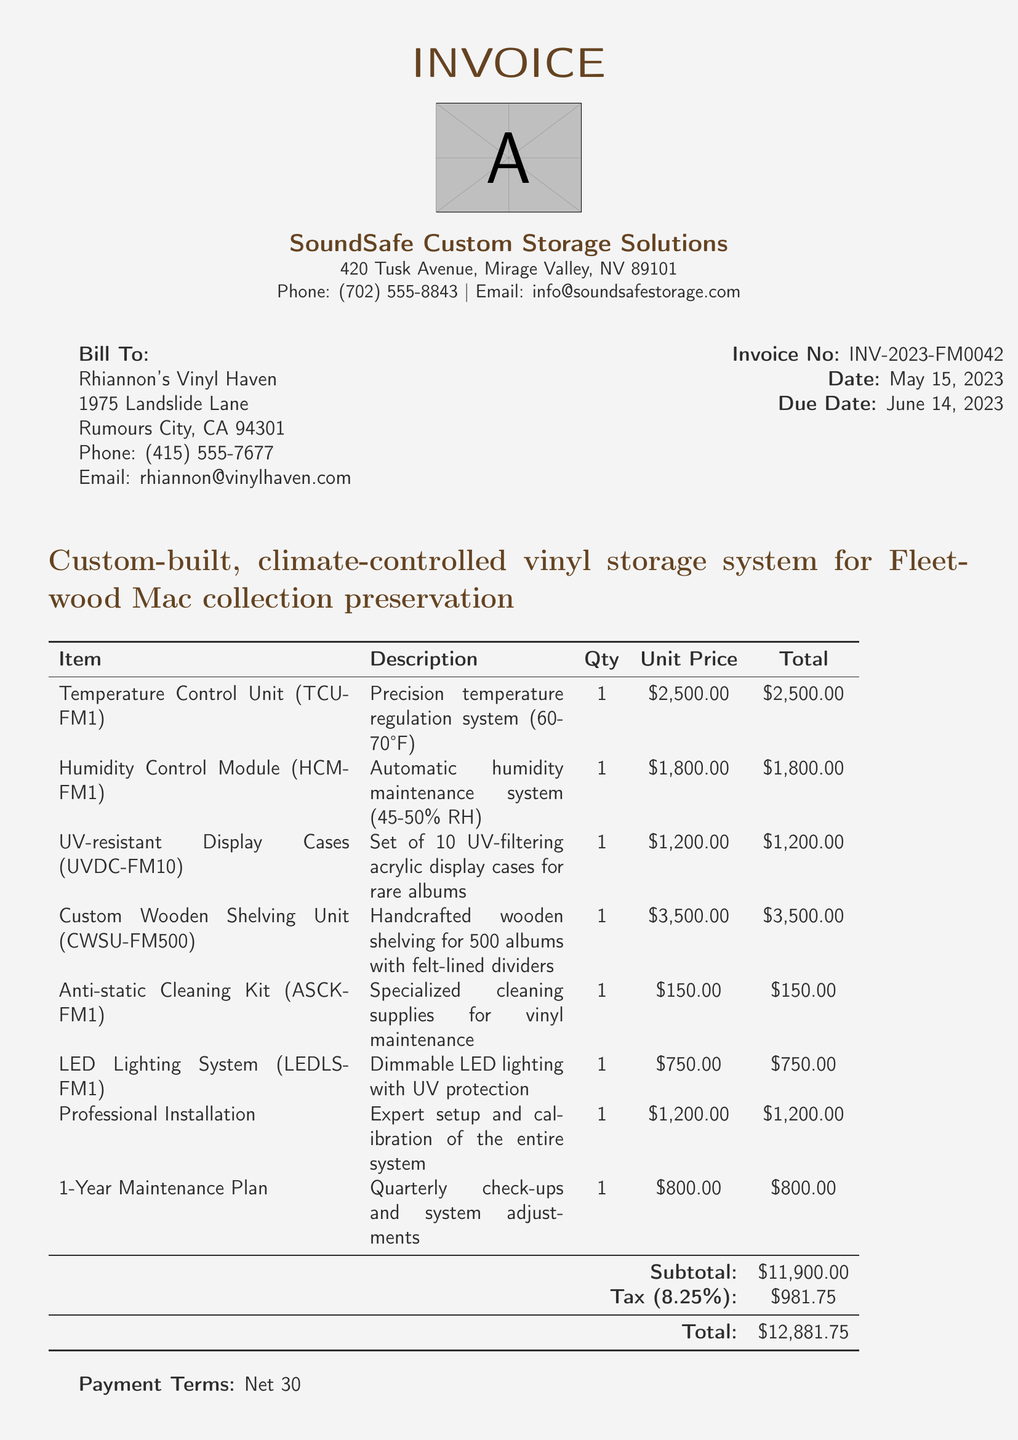what is the invoice number? The invoice number is clearly stated in the document under invoice details.
Answer: INV-2023-FM0042 what is the date of the invoice? The date of the invoice is mentioned along with the invoice number in the document.
Answer: May 15, 2023 who is the vendor? The vendor's name is listed at the top of the document as the company providing the service.
Answer: SoundSafe Custom Storage Solutions how many items are in the system description? The system components listed in the invoice detail the different items included in the custom-built system.
Answer: 6 what is the total amount due? The total amount is calculated at the end of the invoice summing the subtotal and tax.
Answer: $12,881.75 what type of warranty is provided? The warranty information is mentioned toward the end of the document, detailing the type of warranty on hardware components.
Answer: 5-year limited warranty what is included in the additional services? The additional services section specifies two services provided with the invoice, requiring clients to consider for maintenance and installation.
Answer: Professional Installation, 1-Year Maintenance Plan what is the humidity control setting specified? The humidity control setting is described in one of the system component descriptions in the document.
Answer: 45-50% RH what is the payment term stated in the invoice? The payment terms regarding how long the customer has to pay are included near the bottom of the document.
Answer: Net 30 